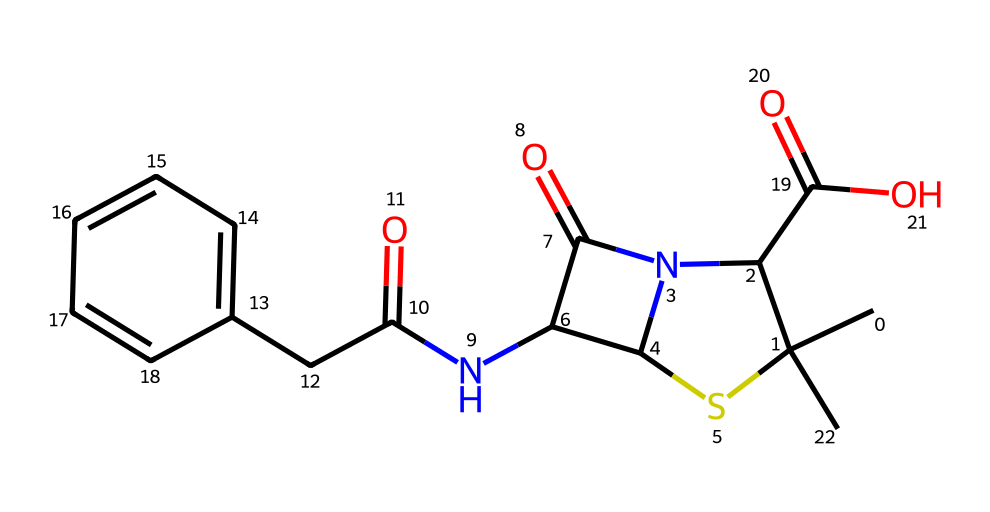What is the number of sulfur atoms in this chemical structure? The SMILES notation indicates the presence of a sulfur atom. In the structure, the ‘S’ in ‘C(S1)’ shows there is one sulfur atom connected to a carbon.
Answer: one How many nitrogen atoms are present in this compound? Analyzing the SMILES, we can identify the nitrogen atoms by the ‘N’ symbols in the structure. There are two occurrences of 'N', indicating two nitrogen atoms in the compound.
Answer: two What type of functional group is present in the antibiotic penicillin? The structure includes a carbonyl group (C=O) and an amide (C(=O)N). The presence of the amide and carboxylic acid functional groups is typical in penicillin.
Answer: amide Which part of the compound indicates it is an organosulfur compound? The structure contains a sulfur atom, indicated by the symbol 'S'. Additionally, the carbon attached to sulfur helps classify this compound as organosulfur.
Answer: sulfur atom How many rings are present in the structure of penicillin? By examining the structure, we identify a ring formed by carbons and the sulfur, noted in the SMILES. Here it represents a cyclic structure indicating that there is one ring present.
Answer: one What characteristic does the presence of sulfur give to penicillin? The inclusion of sulfur in the structure often enhances the biological activity of the compound due to the unique properties of sulfur-related functional groups such as thiols or thioethers.
Answer: biological activity 